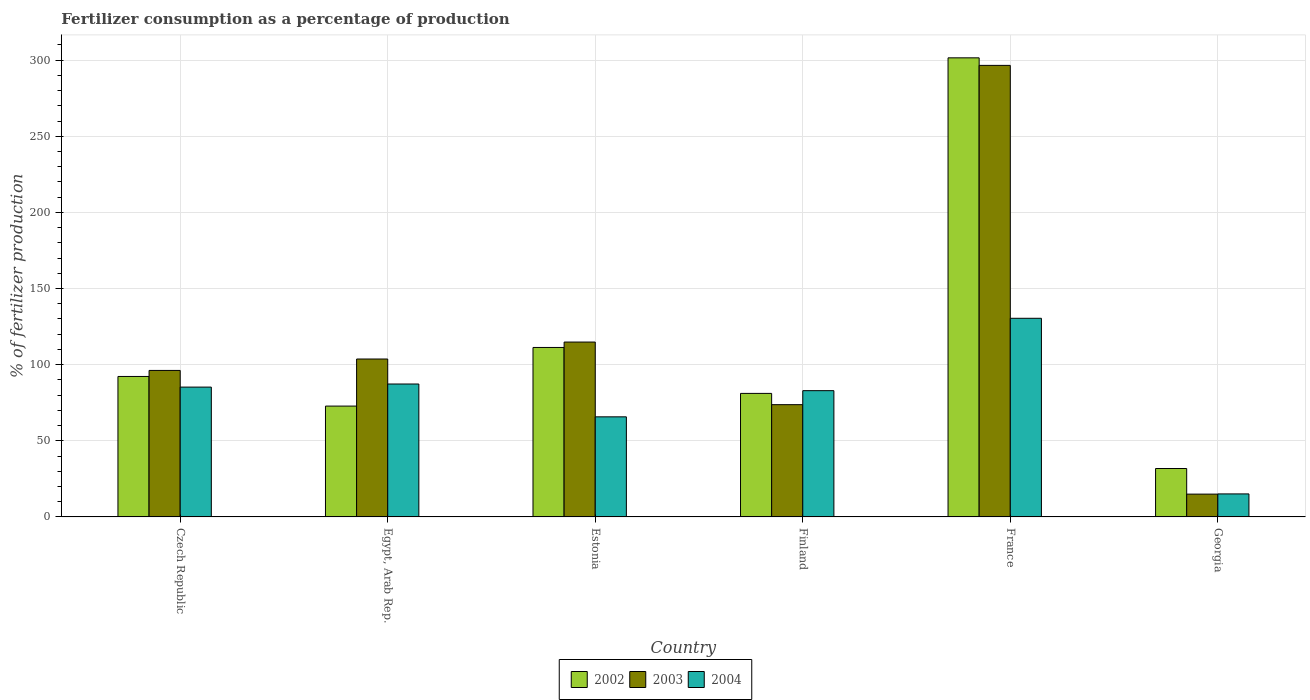How many different coloured bars are there?
Offer a terse response. 3. Are the number of bars per tick equal to the number of legend labels?
Your answer should be very brief. Yes. What is the label of the 1st group of bars from the left?
Keep it short and to the point. Czech Republic. In how many cases, is the number of bars for a given country not equal to the number of legend labels?
Ensure brevity in your answer.  0. What is the percentage of fertilizers consumed in 2002 in Egypt, Arab Rep.?
Ensure brevity in your answer.  72.8. Across all countries, what is the maximum percentage of fertilizers consumed in 2002?
Your answer should be compact. 301.53. Across all countries, what is the minimum percentage of fertilizers consumed in 2004?
Provide a short and direct response. 15.12. In which country was the percentage of fertilizers consumed in 2003 minimum?
Give a very brief answer. Georgia. What is the total percentage of fertilizers consumed in 2002 in the graph?
Provide a short and direct response. 690.84. What is the difference between the percentage of fertilizers consumed in 2004 in Czech Republic and that in Estonia?
Offer a terse response. 19.53. What is the difference between the percentage of fertilizers consumed in 2003 in Georgia and the percentage of fertilizers consumed in 2002 in France?
Keep it short and to the point. -286.54. What is the average percentage of fertilizers consumed in 2002 per country?
Provide a short and direct response. 115.14. What is the difference between the percentage of fertilizers consumed of/in 2004 and percentage of fertilizers consumed of/in 2002 in Czech Republic?
Your answer should be very brief. -6.99. What is the ratio of the percentage of fertilizers consumed in 2004 in Finland to that in France?
Ensure brevity in your answer.  0.64. What is the difference between the highest and the second highest percentage of fertilizers consumed in 2004?
Offer a terse response. 45.19. What is the difference between the highest and the lowest percentage of fertilizers consumed in 2002?
Your answer should be very brief. 269.72. In how many countries, is the percentage of fertilizers consumed in 2003 greater than the average percentage of fertilizers consumed in 2003 taken over all countries?
Make the answer very short. 1. What does the 1st bar from the left in France represents?
Provide a short and direct response. 2002. How many bars are there?
Keep it short and to the point. 18. Are all the bars in the graph horizontal?
Offer a very short reply. No. How many countries are there in the graph?
Keep it short and to the point. 6. What is the difference between two consecutive major ticks on the Y-axis?
Keep it short and to the point. 50. Are the values on the major ticks of Y-axis written in scientific E-notation?
Keep it short and to the point. No. Does the graph contain any zero values?
Provide a succinct answer. No. Does the graph contain grids?
Keep it short and to the point. Yes. How are the legend labels stacked?
Your answer should be compact. Horizontal. What is the title of the graph?
Make the answer very short. Fertilizer consumption as a percentage of production. Does "1961" appear as one of the legend labels in the graph?
Provide a succinct answer. No. What is the label or title of the Y-axis?
Offer a very short reply. % of fertilizer production. What is the % of fertilizer production of 2002 in Czech Republic?
Your answer should be very brief. 92.26. What is the % of fertilizer production in 2003 in Czech Republic?
Offer a very short reply. 96.22. What is the % of fertilizer production in 2004 in Czech Republic?
Offer a terse response. 85.27. What is the % of fertilizer production in 2002 in Egypt, Arab Rep.?
Provide a succinct answer. 72.8. What is the % of fertilizer production in 2003 in Egypt, Arab Rep.?
Offer a very short reply. 103.72. What is the % of fertilizer production of 2004 in Egypt, Arab Rep.?
Provide a short and direct response. 87.3. What is the % of fertilizer production of 2002 in Estonia?
Your response must be concise. 111.3. What is the % of fertilizer production of 2003 in Estonia?
Ensure brevity in your answer.  114.85. What is the % of fertilizer production in 2004 in Estonia?
Your answer should be compact. 65.74. What is the % of fertilizer production in 2002 in Finland?
Make the answer very short. 81.14. What is the % of fertilizer production in 2003 in Finland?
Your response must be concise. 73.73. What is the % of fertilizer production in 2004 in Finland?
Your answer should be very brief. 82.93. What is the % of fertilizer production of 2002 in France?
Give a very brief answer. 301.53. What is the % of fertilizer production in 2003 in France?
Give a very brief answer. 296.56. What is the % of fertilizer production of 2004 in France?
Your response must be concise. 130.46. What is the % of fertilizer production of 2002 in Georgia?
Your answer should be compact. 31.81. What is the % of fertilizer production of 2003 in Georgia?
Your answer should be compact. 14.99. What is the % of fertilizer production in 2004 in Georgia?
Provide a short and direct response. 15.12. Across all countries, what is the maximum % of fertilizer production of 2002?
Your answer should be very brief. 301.53. Across all countries, what is the maximum % of fertilizer production in 2003?
Provide a short and direct response. 296.56. Across all countries, what is the maximum % of fertilizer production of 2004?
Your response must be concise. 130.46. Across all countries, what is the minimum % of fertilizer production of 2002?
Ensure brevity in your answer.  31.81. Across all countries, what is the minimum % of fertilizer production in 2003?
Offer a very short reply. 14.99. Across all countries, what is the minimum % of fertilizer production of 2004?
Your answer should be compact. 15.12. What is the total % of fertilizer production of 2002 in the graph?
Provide a succinct answer. 690.84. What is the total % of fertilizer production in 2003 in the graph?
Keep it short and to the point. 700.07. What is the total % of fertilizer production of 2004 in the graph?
Offer a very short reply. 466.82. What is the difference between the % of fertilizer production in 2002 in Czech Republic and that in Egypt, Arab Rep.?
Keep it short and to the point. 19.47. What is the difference between the % of fertilizer production of 2003 in Czech Republic and that in Egypt, Arab Rep.?
Keep it short and to the point. -7.5. What is the difference between the % of fertilizer production of 2004 in Czech Republic and that in Egypt, Arab Rep.?
Give a very brief answer. -2.03. What is the difference between the % of fertilizer production in 2002 in Czech Republic and that in Estonia?
Offer a terse response. -19.04. What is the difference between the % of fertilizer production in 2003 in Czech Republic and that in Estonia?
Your response must be concise. -18.63. What is the difference between the % of fertilizer production in 2004 in Czech Republic and that in Estonia?
Your answer should be very brief. 19.53. What is the difference between the % of fertilizer production in 2002 in Czech Republic and that in Finland?
Provide a succinct answer. 11.12. What is the difference between the % of fertilizer production of 2003 in Czech Republic and that in Finland?
Keep it short and to the point. 22.49. What is the difference between the % of fertilizer production of 2004 in Czech Republic and that in Finland?
Your answer should be very brief. 2.34. What is the difference between the % of fertilizer production in 2002 in Czech Republic and that in France?
Provide a succinct answer. -209.27. What is the difference between the % of fertilizer production of 2003 in Czech Republic and that in France?
Provide a succinct answer. -200.34. What is the difference between the % of fertilizer production of 2004 in Czech Republic and that in France?
Your response must be concise. -45.19. What is the difference between the % of fertilizer production in 2002 in Czech Republic and that in Georgia?
Offer a terse response. 60.45. What is the difference between the % of fertilizer production of 2003 in Czech Republic and that in Georgia?
Your answer should be compact. 81.24. What is the difference between the % of fertilizer production in 2004 in Czech Republic and that in Georgia?
Offer a very short reply. 70.15. What is the difference between the % of fertilizer production of 2002 in Egypt, Arab Rep. and that in Estonia?
Offer a terse response. -38.51. What is the difference between the % of fertilizer production of 2003 in Egypt, Arab Rep. and that in Estonia?
Provide a succinct answer. -11.13. What is the difference between the % of fertilizer production in 2004 in Egypt, Arab Rep. and that in Estonia?
Your response must be concise. 21.56. What is the difference between the % of fertilizer production in 2002 in Egypt, Arab Rep. and that in Finland?
Ensure brevity in your answer.  -8.34. What is the difference between the % of fertilizer production of 2003 in Egypt, Arab Rep. and that in Finland?
Give a very brief answer. 29.99. What is the difference between the % of fertilizer production of 2004 in Egypt, Arab Rep. and that in Finland?
Ensure brevity in your answer.  4.37. What is the difference between the % of fertilizer production of 2002 in Egypt, Arab Rep. and that in France?
Offer a very short reply. -228.73. What is the difference between the % of fertilizer production of 2003 in Egypt, Arab Rep. and that in France?
Offer a very short reply. -192.85. What is the difference between the % of fertilizer production of 2004 in Egypt, Arab Rep. and that in France?
Give a very brief answer. -43.16. What is the difference between the % of fertilizer production of 2002 in Egypt, Arab Rep. and that in Georgia?
Provide a short and direct response. 40.99. What is the difference between the % of fertilizer production of 2003 in Egypt, Arab Rep. and that in Georgia?
Your answer should be very brief. 88.73. What is the difference between the % of fertilizer production of 2004 in Egypt, Arab Rep. and that in Georgia?
Ensure brevity in your answer.  72.18. What is the difference between the % of fertilizer production of 2002 in Estonia and that in Finland?
Offer a very short reply. 30.17. What is the difference between the % of fertilizer production in 2003 in Estonia and that in Finland?
Your response must be concise. 41.12. What is the difference between the % of fertilizer production in 2004 in Estonia and that in Finland?
Provide a succinct answer. -17.19. What is the difference between the % of fertilizer production of 2002 in Estonia and that in France?
Offer a terse response. -190.22. What is the difference between the % of fertilizer production in 2003 in Estonia and that in France?
Your response must be concise. -181.71. What is the difference between the % of fertilizer production of 2004 in Estonia and that in France?
Provide a succinct answer. -64.72. What is the difference between the % of fertilizer production of 2002 in Estonia and that in Georgia?
Provide a succinct answer. 79.5. What is the difference between the % of fertilizer production in 2003 in Estonia and that in Georgia?
Make the answer very short. 99.86. What is the difference between the % of fertilizer production of 2004 in Estonia and that in Georgia?
Keep it short and to the point. 50.62. What is the difference between the % of fertilizer production in 2002 in Finland and that in France?
Provide a short and direct response. -220.39. What is the difference between the % of fertilizer production of 2003 in Finland and that in France?
Your response must be concise. -222.83. What is the difference between the % of fertilizer production of 2004 in Finland and that in France?
Give a very brief answer. -47.53. What is the difference between the % of fertilizer production in 2002 in Finland and that in Georgia?
Your response must be concise. 49.33. What is the difference between the % of fertilizer production of 2003 in Finland and that in Georgia?
Keep it short and to the point. 58.75. What is the difference between the % of fertilizer production in 2004 in Finland and that in Georgia?
Your response must be concise. 67.81. What is the difference between the % of fertilizer production in 2002 in France and that in Georgia?
Your answer should be compact. 269.72. What is the difference between the % of fertilizer production in 2003 in France and that in Georgia?
Keep it short and to the point. 281.58. What is the difference between the % of fertilizer production of 2004 in France and that in Georgia?
Ensure brevity in your answer.  115.34. What is the difference between the % of fertilizer production in 2002 in Czech Republic and the % of fertilizer production in 2003 in Egypt, Arab Rep.?
Give a very brief answer. -11.46. What is the difference between the % of fertilizer production of 2002 in Czech Republic and the % of fertilizer production of 2004 in Egypt, Arab Rep.?
Give a very brief answer. 4.96. What is the difference between the % of fertilizer production in 2003 in Czech Republic and the % of fertilizer production in 2004 in Egypt, Arab Rep.?
Keep it short and to the point. 8.92. What is the difference between the % of fertilizer production in 2002 in Czech Republic and the % of fertilizer production in 2003 in Estonia?
Give a very brief answer. -22.59. What is the difference between the % of fertilizer production of 2002 in Czech Republic and the % of fertilizer production of 2004 in Estonia?
Provide a short and direct response. 26.52. What is the difference between the % of fertilizer production in 2003 in Czech Republic and the % of fertilizer production in 2004 in Estonia?
Provide a succinct answer. 30.48. What is the difference between the % of fertilizer production in 2002 in Czech Republic and the % of fertilizer production in 2003 in Finland?
Offer a terse response. 18.53. What is the difference between the % of fertilizer production in 2002 in Czech Republic and the % of fertilizer production in 2004 in Finland?
Make the answer very short. 9.33. What is the difference between the % of fertilizer production of 2003 in Czech Republic and the % of fertilizer production of 2004 in Finland?
Make the answer very short. 13.29. What is the difference between the % of fertilizer production of 2002 in Czech Republic and the % of fertilizer production of 2003 in France?
Your answer should be compact. -204.3. What is the difference between the % of fertilizer production in 2002 in Czech Republic and the % of fertilizer production in 2004 in France?
Offer a terse response. -38.2. What is the difference between the % of fertilizer production in 2003 in Czech Republic and the % of fertilizer production in 2004 in France?
Ensure brevity in your answer.  -34.24. What is the difference between the % of fertilizer production of 2002 in Czech Republic and the % of fertilizer production of 2003 in Georgia?
Offer a terse response. 77.28. What is the difference between the % of fertilizer production of 2002 in Czech Republic and the % of fertilizer production of 2004 in Georgia?
Ensure brevity in your answer.  77.14. What is the difference between the % of fertilizer production of 2003 in Czech Republic and the % of fertilizer production of 2004 in Georgia?
Your answer should be compact. 81.1. What is the difference between the % of fertilizer production of 2002 in Egypt, Arab Rep. and the % of fertilizer production of 2003 in Estonia?
Your answer should be very brief. -42.05. What is the difference between the % of fertilizer production in 2002 in Egypt, Arab Rep. and the % of fertilizer production in 2004 in Estonia?
Your answer should be very brief. 7.06. What is the difference between the % of fertilizer production of 2003 in Egypt, Arab Rep. and the % of fertilizer production of 2004 in Estonia?
Offer a very short reply. 37.98. What is the difference between the % of fertilizer production of 2002 in Egypt, Arab Rep. and the % of fertilizer production of 2003 in Finland?
Ensure brevity in your answer.  -0.94. What is the difference between the % of fertilizer production in 2002 in Egypt, Arab Rep. and the % of fertilizer production in 2004 in Finland?
Keep it short and to the point. -10.14. What is the difference between the % of fertilizer production in 2003 in Egypt, Arab Rep. and the % of fertilizer production in 2004 in Finland?
Ensure brevity in your answer.  20.79. What is the difference between the % of fertilizer production in 2002 in Egypt, Arab Rep. and the % of fertilizer production in 2003 in France?
Provide a short and direct response. -223.77. What is the difference between the % of fertilizer production in 2002 in Egypt, Arab Rep. and the % of fertilizer production in 2004 in France?
Your answer should be compact. -57.66. What is the difference between the % of fertilizer production of 2003 in Egypt, Arab Rep. and the % of fertilizer production of 2004 in France?
Offer a terse response. -26.74. What is the difference between the % of fertilizer production of 2002 in Egypt, Arab Rep. and the % of fertilizer production of 2003 in Georgia?
Your answer should be very brief. 57.81. What is the difference between the % of fertilizer production in 2002 in Egypt, Arab Rep. and the % of fertilizer production in 2004 in Georgia?
Your answer should be very brief. 57.68. What is the difference between the % of fertilizer production of 2003 in Egypt, Arab Rep. and the % of fertilizer production of 2004 in Georgia?
Your answer should be very brief. 88.6. What is the difference between the % of fertilizer production in 2002 in Estonia and the % of fertilizer production in 2003 in Finland?
Offer a terse response. 37.57. What is the difference between the % of fertilizer production in 2002 in Estonia and the % of fertilizer production in 2004 in Finland?
Ensure brevity in your answer.  28.37. What is the difference between the % of fertilizer production in 2003 in Estonia and the % of fertilizer production in 2004 in Finland?
Ensure brevity in your answer.  31.92. What is the difference between the % of fertilizer production in 2002 in Estonia and the % of fertilizer production in 2003 in France?
Make the answer very short. -185.26. What is the difference between the % of fertilizer production of 2002 in Estonia and the % of fertilizer production of 2004 in France?
Make the answer very short. -19.16. What is the difference between the % of fertilizer production in 2003 in Estonia and the % of fertilizer production in 2004 in France?
Your answer should be compact. -15.61. What is the difference between the % of fertilizer production in 2002 in Estonia and the % of fertilizer production in 2003 in Georgia?
Provide a short and direct response. 96.32. What is the difference between the % of fertilizer production of 2002 in Estonia and the % of fertilizer production of 2004 in Georgia?
Provide a short and direct response. 96.19. What is the difference between the % of fertilizer production of 2003 in Estonia and the % of fertilizer production of 2004 in Georgia?
Provide a succinct answer. 99.73. What is the difference between the % of fertilizer production of 2002 in Finland and the % of fertilizer production of 2003 in France?
Give a very brief answer. -215.43. What is the difference between the % of fertilizer production of 2002 in Finland and the % of fertilizer production of 2004 in France?
Your answer should be compact. -49.32. What is the difference between the % of fertilizer production in 2003 in Finland and the % of fertilizer production in 2004 in France?
Provide a succinct answer. -56.73. What is the difference between the % of fertilizer production of 2002 in Finland and the % of fertilizer production of 2003 in Georgia?
Offer a very short reply. 66.15. What is the difference between the % of fertilizer production of 2002 in Finland and the % of fertilizer production of 2004 in Georgia?
Ensure brevity in your answer.  66.02. What is the difference between the % of fertilizer production of 2003 in Finland and the % of fertilizer production of 2004 in Georgia?
Your answer should be very brief. 58.61. What is the difference between the % of fertilizer production of 2002 in France and the % of fertilizer production of 2003 in Georgia?
Ensure brevity in your answer.  286.54. What is the difference between the % of fertilizer production in 2002 in France and the % of fertilizer production in 2004 in Georgia?
Make the answer very short. 286.41. What is the difference between the % of fertilizer production of 2003 in France and the % of fertilizer production of 2004 in Georgia?
Give a very brief answer. 281.45. What is the average % of fertilizer production of 2002 per country?
Your response must be concise. 115.14. What is the average % of fertilizer production of 2003 per country?
Give a very brief answer. 116.68. What is the average % of fertilizer production in 2004 per country?
Keep it short and to the point. 77.8. What is the difference between the % of fertilizer production in 2002 and % of fertilizer production in 2003 in Czech Republic?
Make the answer very short. -3.96. What is the difference between the % of fertilizer production in 2002 and % of fertilizer production in 2004 in Czech Republic?
Offer a terse response. 6.99. What is the difference between the % of fertilizer production of 2003 and % of fertilizer production of 2004 in Czech Republic?
Provide a short and direct response. 10.95. What is the difference between the % of fertilizer production in 2002 and % of fertilizer production in 2003 in Egypt, Arab Rep.?
Make the answer very short. -30.92. What is the difference between the % of fertilizer production in 2002 and % of fertilizer production in 2004 in Egypt, Arab Rep.?
Your answer should be very brief. -14.5. What is the difference between the % of fertilizer production in 2003 and % of fertilizer production in 2004 in Egypt, Arab Rep.?
Offer a terse response. 16.42. What is the difference between the % of fertilizer production of 2002 and % of fertilizer production of 2003 in Estonia?
Provide a short and direct response. -3.55. What is the difference between the % of fertilizer production in 2002 and % of fertilizer production in 2004 in Estonia?
Provide a short and direct response. 45.57. What is the difference between the % of fertilizer production in 2003 and % of fertilizer production in 2004 in Estonia?
Ensure brevity in your answer.  49.11. What is the difference between the % of fertilizer production in 2002 and % of fertilizer production in 2003 in Finland?
Your answer should be very brief. 7.41. What is the difference between the % of fertilizer production of 2002 and % of fertilizer production of 2004 in Finland?
Keep it short and to the point. -1.79. What is the difference between the % of fertilizer production in 2003 and % of fertilizer production in 2004 in Finland?
Keep it short and to the point. -9.2. What is the difference between the % of fertilizer production of 2002 and % of fertilizer production of 2003 in France?
Give a very brief answer. 4.96. What is the difference between the % of fertilizer production in 2002 and % of fertilizer production in 2004 in France?
Your answer should be very brief. 171.07. What is the difference between the % of fertilizer production of 2003 and % of fertilizer production of 2004 in France?
Keep it short and to the point. 166.1. What is the difference between the % of fertilizer production of 2002 and % of fertilizer production of 2003 in Georgia?
Ensure brevity in your answer.  16.82. What is the difference between the % of fertilizer production of 2002 and % of fertilizer production of 2004 in Georgia?
Offer a terse response. 16.69. What is the difference between the % of fertilizer production of 2003 and % of fertilizer production of 2004 in Georgia?
Provide a short and direct response. -0.13. What is the ratio of the % of fertilizer production of 2002 in Czech Republic to that in Egypt, Arab Rep.?
Provide a succinct answer. 1.27. What is the ratio of the % of fertilizer production in 2003 in Czech Republic to that in Egypt, Arab Rep.?
Offer a terse response. 0.93. What is the ratio of the % of fertilizer production in 2004 in Czech Republic to that in Egypt, Arab Rep.?
Ensure brevity in your answer.  0.98. What is the ratio of the % of fertilizer production in 2002 in Czech Republic to that in Estonia?
Keep it short and to the point. 0.83. What is the ratio of the % of fertilizer production of 2003 in Czech Republic to that in Estonia?
Offer a very short reply. 0.84. What is the ratio of the % of fertilizer production in 2004 in Czech Republic to that in Estonia?
Provide a short and direct response. 1.3. What is the ratio of the % of fertilizer production of 2002 in Czech Republic to that in Finland?
Offer a terse response. 1.14. What is the ratio of the % of fertilizer production of 2003 in Czech Republic to that in Finland?
Keep it short and to the point. 1.3. What is the ratio of the % of fertilizer production in 2004 in Czech Republic to that in Finland?
Give a very brief answer. 1.03. What is the ratio of the % of fertilizer production in 2002 in Czech Republic to that in France?
Provide a succinct answer. 0.31. What is the ratio of the % of fertilizer production in 2003 in Czech Republic to that in France?
Your answer should be very brief. 0.32. What is the ratio of the % of fertilizer production in 2004 in Czech Republic to that in France?
Offer a very short reply. 0.65. What is the ratio of the % of fertilizer production in 2002 in Czech Republic to that in Georgia?
Your response must be concise. 2.9. What is the ratio of the % of fertilizer production of 2003 in Czech Republic to that in Georgia?
Ensure brevity in your answer.  6.42. What is the ratio of the % of fertilizer production in 2004 in Czech Republic to that in Georgia?
Keep it short and to the point. 5.64. What is the ratio of the % of fertilizer production in 2002 in Egypt, Arab Rep. to that in Estonia?
Offer a very short reply. 0.65. What is the ratio of the % of fertilizer production in 2003 in Egypt, Arab Rep. to that in Estonia?
Your response must be concise. 0.9. What is the ratio of the % of fertilizer production in 2004 in Egypt, Arab Rep. to that in Estonia?
Your answer should be very brief. 1.33. What is the ratio of the % of fertilizer production in 2002 in Egypt, Arab Rep. to that in Finland?
Offer a very short reply. 0.9. What is the ratio of the % of fertilizer production in 2003 in Egypt, Arab Rep. to that in Finland?
Offer a very short reply. 1.41. What is the ratio of the % of fertilizer production in 2004 in Egypt, Arab Rep. to that in Finland?
Ensure brevity in your answer.  1.05. What is the ratio of the % of fertilizer production of 2002 in Egypt, Arab Rep. to that in France?
Offer a very short reply. 0.24. What is the ratio of the % of fertilizer production of 2003 in Egypt, Arab Rep. to that in France?
Offer a terse response. 0.35. What is the ratio of the % of fertilizer production of 2004 in Egypt, Arab Rep. to that in France?
Your response must be concise. 0.67. What is the ratio of the % of fertilizer production in 2002 in Egypt, Arab Rep. to that in Georgia?
Provide a short and direct response. 2.29. What is the ratio of the % of fertilizer production in 2003 in Egypt, Arab Rep. to that in Georgia?
Provide a short and direct response. 6.92. What is the ratio of the % of fertilizer production in 2004 in Egypt, Arab Rep. to that in Georgia?
Keep it short and to the point. 5.77. What is the ratio of the % of fertilizer production of 2002 in Estonia to that in Finland?
Ensure brevity in your answer.  1.37. What is the ratio of the % of fertilizer production of 2003 in Estonia to that in Finland?
Make the answer very short. 1.56. What is the ratio of the % of fertilizer production in 2004 in Estonia to that in Finland?
Offer a very short reply. 0.79. What is the ratio of the % of fertilizer production of 2002 in Estonia to that in France?
Offer a terse response. 0.37. What is the ratio of the % of fertilizer production of 2003 in Estonia to that in France?
Your answer should be very brief. 0.39. What is the ratio of the % of fertilizer production in 2004 in Estonia to that in France?
Keep it short and to the point. 0.5. What is the ratio of the % of fertilizer production of 2002 in Estonia to that in Georgia?
Provide a short and direct response. 3.5. What is the ratio of the % of fertilizer production of 2003 in Estonia to that in Georgia?
Your answer should be very brief. 7.66. What is the ratio of the % of fertilizer production of 2004 in Estonia to that in Georgia?
Make the answer very short. 4.35. What is the ratio of the % of fertilizer production in 2002 in Finland to that in France?
Your answer should be compact. 0.27. What is the ratio of the % of fertilizer production of 2003 in Finland to that in France?
Your response must be concise. 0.25. What is the ratio of the % of fertilizer production of 2004 in Finland to that in France?
Your response must be concise. 0.64. What is the ratio of the % of fertilizer production of 2002 in Finland to that in Georgia?
Provide a succinct answer. 2.55. What is the ratio of the % of fertilizer production of 2003 in Finland to that in Georgia?
Your answer should be compact. 4.92. What is the ratio of the % of fertilizer production of 2004 in Finland to that in Georgia?
Make the answer very short. 5.49. What is the ratio of the % of fertilizer production of 2002 in France to that in Georgia?
Ensure brevity in your answer.  9.48. What is the ratio of the % of fertilizer production of 2003 in France to that in Georgia?
Your answer should be very brief. 19.79. What is the ratio of the % of fertilizer production of 2004 in France to that in Georgia?
Your response must be concise. 8.63. What is the difference between the highest and the second highest % of fertilizer production in 2002?
Your answer should be very brief. 190.22. What is the difference between the highest and the second highest % of fertilizer production in 2003?
Ensure brevity in your answer.  181.71. What is the difference between the highest and the second highest % of fertilizer production of 2004?
Make the answer very short. 43.16. What is the difference between the highest and the lowest % of fertilizer production in 2002?
Provide a succinct answer. 269.72. What is the difference between the highest and the lowest % of fertilizer production in 2003?
Give a very brief answer. 281.58. What is the difference between the highest and the lowest % of fertilizer production of 2004?
Provide a short and direct response. 115.34. 